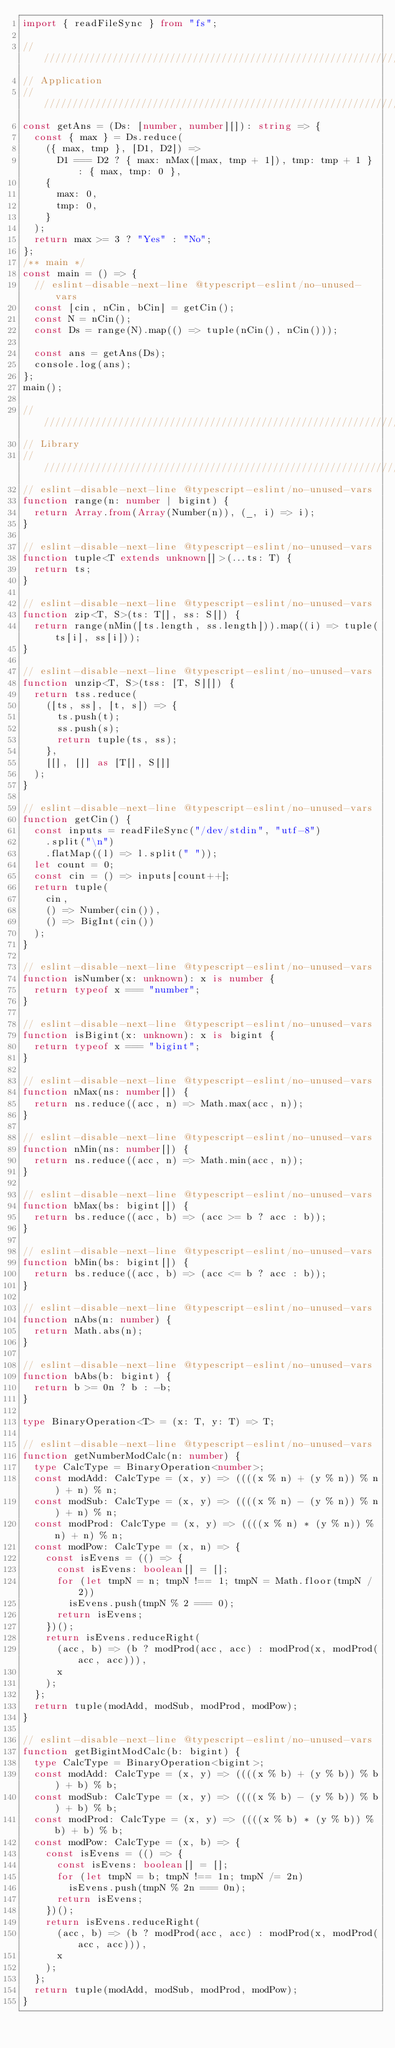Convert code to text. <code><loc_0><loc_0><loc_500><loc_500><_TypeScript_>import { readFileSync } from "fs";

////////////////////////////////////////////////////////////////////////////////
// Application
////////////////////////////////////////////////////////////////////////////////
const getAns = (Ds: [number, number][]): string => {
  const { max } = Ds.reduce(
    ({ max, tmp }, [D1, D2]) =>
      D1 === D2 ? { max: nMax([max, tmp + 1]), tmp: tmp + 1 } : { max, tmp: 0 },
    {
      max: 0,
      tmp: 0,
    }
  );
  return max >= 3 ? "Yes" : "No";
};
/** main */
const main = () => {
  // eslint-disable-next-line @typescript-eslint/no-unused-vars
  const [cin, nCin, bCin] = getCin();
  const N = nCin();
  const Ds = range(N).map(() => tuple(nCin(), nCin()));

  const ans = getAns(Ds);
  console.log(ans);
};
main();

////////////////////////////////////////////////////////////////////////////////
// Library
////////////////////////////////////////////////////////////////////////////////
// eslint-disable-next-line @typescript-eslint/no-unused-vars
function range(n: number | bigint) {
  return Array.from(Array(Number(n)), (_, i) => i);
}

// eslint-disable-next-line @typescript-eslint/no-unused-vars
function tuple<T extends unknown[]>(...ts: T) {
  return ts;
}

// eslint-disable-next-line @typescript-eslint/no-unused-vars
function zip<T, S>(ts: T[], ss: S[]) {
  return range(nMin([ts.length, ss.length])).map((i) => tuple(ts[i], ss[i]));
}

// eslint-disable-next-line @typescript-eslint/no-unused-vars
function unzip<T, S>(tss: [T, S][]) {
  return tss.reduce(
    ([ts, ss], [t, s]) => {
      ts.push(t);
      ss.push(s);
      return tuple(ts, ss);
    },
    [[], []] as [T[], S[]]
  );
}

// eslint-disable-next-line @typescript-eslint/no-unused-vars
function getCin() {
  const inputs = readFileSync("/dev/stdin", "utf-8")
    .split("\n")
    .flatMap((l) => l.split(" "));
  let count = 0;
  const cin = () => inputs[count++];
  return tuple(
    cin,
    () => Number(cin()),
    () => BigInt(cin())
  );
}

// eslint-disable-next-line @typescript-eslint/no-unused-vars
function isNumber(x: unknown): x is number {
  return typeof x === "number";
}

// eslint-disable-next-line @typescript-eslint/no-unused-vars
function isBigint(x: unknown): x is bigint {
  return typeof x === "bigint";
}

// eslint-disable-next-line @typescript-eslint/no-unused-vars
function nMax(ns: number[]) {
  return ns.reduce((acc, n) => Math.max(acc, n));
}

// eslint-disable-next-line @typescript-eslint/no-unused-vars
function nMin(ns: number[]) {
  return ns.reduce((acc, n) => Math.min(acc, n));
}

// eslint-disable-next-line @typescript-eslint/no-unused-vars
function bMax(bs: bigint[]) {
  return bs.reduce((acc, b) => (acc >= b ? acc : b));
}

// eslint-disable-next-line @typescript-eslint/no-unused-vars
function bMin(bs: bigint[]) {
  return bs.reduce((acc, b) => (acc <= b ? acc : b));
}

// eslint-disable-next-line @typescript-eslint/no-unused-vars
function nAbs(n: number) {
  return Math.abs(n);
}

// eslint-disable-next-line @typescript-eslint/no-unused-vars
function bAbs(b: bigint) {
  return b >= 0n ? b : -b;
}

type BinaryOperation<T> = (x: T, y: T) => T;

// eslint-disable-next-line @typescript-eslint/no-unused-vars
function getNumberModCalc(n: number) {
  type CalcType = BinaryOperation<number>;
  const modAdd: CalcType = (x, y) => ((((x % n) + (y % n)) % n) + n) % n;
  const modSub: CalcType = (x, y) => ((((x % n) - (y % n)) % n) + n) % n;
  const modProd: CalcType = (x, y) => ((((x % n) * (y % n)) % n) + n) % n;
  const modPow: CalcType = (x, n) => {
    const isEvens = (() => {
      const isEvens: boolean[] = [];
      for (let tmpN = n; tmpN !== 1; tmpN = Math.floor(tmpN / 2))
        isEvens.push(tmpN % 2 === 0);
      return isEvens;
    })();
    return isEvens.reduceRight(
      (acc, b) => (b ? modProd(acc, acc) : modProd(x, modProd(acc, acc))),
      x
    );
  };
  return tuple(modAdd, modSub, modProd, modPow);
}

// eslint-disable-next-line @typescript-eslint/no-unused-vars
function getBigintModCalc(b: bigint) {
  type CalcType = BinaryOperation<bigint>;
  const modAdd: CalcType = (x, y) => ((((x % b) + (y % b)) % b) + b) % b;
  const modSub: CalcType = (x, y) => ((((x % b) - (y % b)) % b) + b) % b;
  const modProd: CalcType = (x, y) => ((((x % b) * (y % b)) % b) + b) % b;
  const modPow: CalcType = (x, b) => {
    const isEvens = (() => {
      const isEvens: boolean[] = [];
      for (let tmpN = b; tmpN !== 1n; tmpN /= 2n)
        isEvens.push(tmpN % 2n === 0n);
      return isEvens;
    })();
    return isEvens.reduceRight(
      (acc, b) => (b ? modProd(acc, acc) : modProd(x, modProd(acc, acc))),
      x
    );
  };
  return tuple(modAdd, modSub, modProd, modPow);
}
</code> 